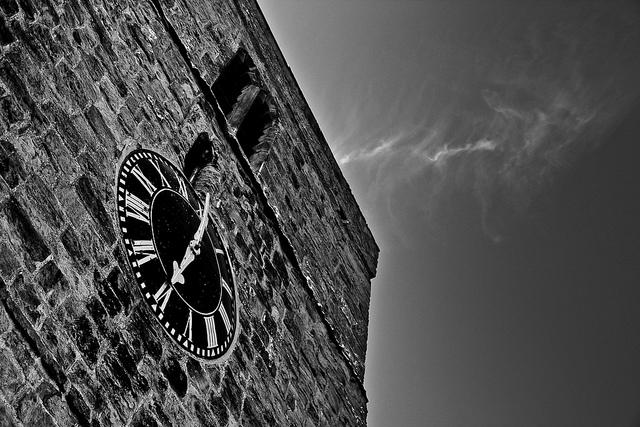What material is the building made of?
Be succinct. Brick. What is the time?
Be succinct. 6:00. Is it a clear or cloudy day?
Answer briefly. Clear. 